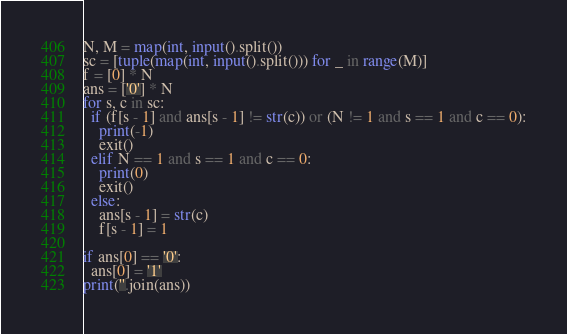<code> <loc_0><loc_0><loc_500><loc_500><_Python_>N, M = map(int, input().split())
sc = [tuple(map(int, input().split())) for _ in range(M)]
f = [0] * N
ans = ['0'] * N
for s, c in sc:
  if (f[s - 1] and ans[s - 1] != str(c)) or (N != 1 and s == 1 and c == 0):
    print(-1)
    exit()
  elif N == 1 and s == 1 and c == 0:
    print(0)
    exit()
  else:
    ans[s - 1] = str(c)
    f[s - 1] = 1
    
if ans[0] == '0':
  ans[0] = '1'
print(''.join(ans))</code> 